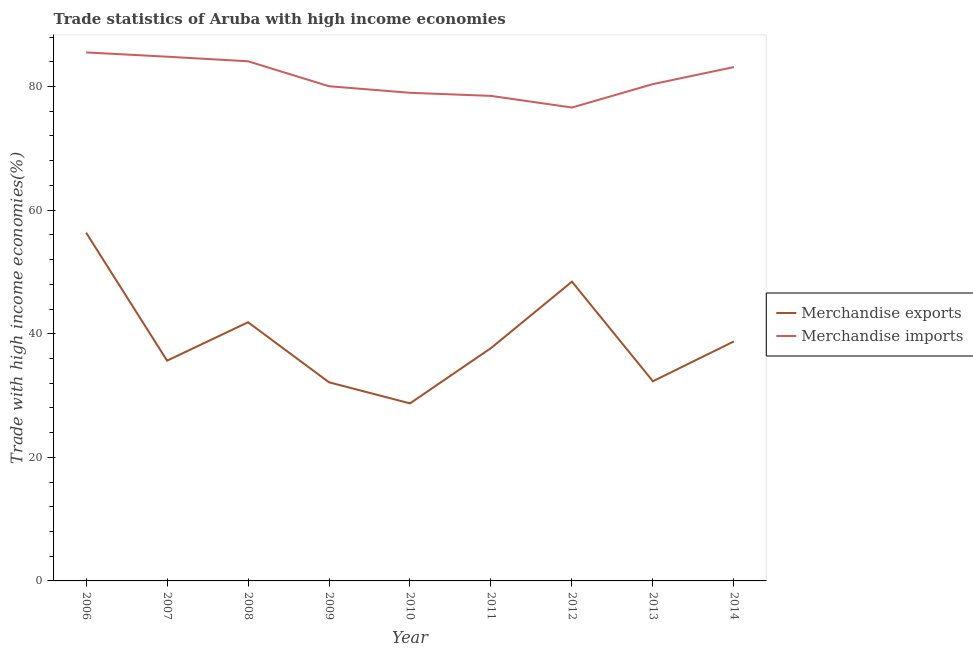What is the merchandise exports in 2008?
Offer a very short reply. 41.86. Across all years, what is the maximum merchandise imports?
Provide a short and direct response. 85.52. Across all years, what is the minimum merchandise imports?
Ensure brevity in your answer.  76.6. In which year was the merchandise imports maximum?
Provide a short and direct response. 2006. In which year was the merchandise exports minimum?
Keep it short and to the point. 2010. What is the total merchandise imports in the graph?
Your answer should be compact. 732.12. What is the difference between the merchandise exports in 2006 and that in 2012?
Your response must be concise. 7.93. What is the difference between the merchandise exports in 2006 and the merchandise imports in 2008?
Keep it short and to the point. -27.73. What is the average merchandise imports per year?
Ensure brevity in your answer.  81.35. In the year 2011, what is the difference between the merchandise exports and merchandise imports?
Your response must be concise. -40.81. What is the ratio of the merchandise imports in 2012 to that in 2013?
Make the answer very short. 0.95. What is the difference between the highest and the second highest merchandise exports?
Provide a short and direct response. 7.93. What is the difference between the highest and the lowest merchandise exports?
Your response must be concise. 27.63. Is the sum of the merchandise imports in 2008 and 2012 greater than the maximum merchandise exports across all years?
Offer a terse response. Yes. Does the merchandise exports monotonically increase over the years?
Give a very brief answer. No. Is the merchandise exports strictly less than the merchandise imports over the years?
Keep it short and to the point. Yes. Are the values on the major ticks of Y-axis written in scientific E-notation?
Ensure brevity in your answer.  No. Does the graph contain any zero values?
Provide a short and direct response. No. Does the graph contain grids?
Provide a short and direct response. No. Where does the legend appear in the graph?
Provide a succinct answer. Center right. How many legend labels are there?
Ensure brevity in your answer.  2. What is the title of the graph?
Provide a short and direct response. Trade statistics of Aruba with high income economies. Does "Measles" appear as one of the legend labels in the graph?
Ensure brevity in your answer.  No. What is the label or title of the X-axis?
Your response must be concise. Year. What is the label or title of the Y-axis?
Provide a short and direct response. Trade with high income economies(%). What is the Trade with high income economies(%) of Merchandise exports in 2006?
Make the answer very short. 56.36. What is the Trade with high income economies(%) of Merchandise imports in 2006?
Your answer should be compact. 85.52. What is the Trade with high income economies(%) of Merchandise exports in 2007?
Make the answer very short. 35.64. What is the Trade with high income economies(%) of Merchandise imports in 2007?
Ensure brevity in your answer.  84.83. What is the Trade with high income economies(%) of Merchandise exports in 2008?
Ensure brevity in your answer.  41.86. What is the Trade with high income economies(%) of Merchandise imports in 2008?
Provide a succinct answer. 84.09. What is the Trade with high income economies(%) of Merchandise exports in 2009?
Your answer should be compact. 32.14. What is the Trade with high income economies(%) of Merchandise imports in 2009?
Your answer should be compact. 80.05. What is the Trade with high income economies(%) of Merchandise exports in 2010?
Your response must be concise. 28.73. What is the Trade with high income economies(%) of Merchandise imports in 2010?
Your answer should be compact. 78.99. What is the Trade with high income economies(%) in Merchandise exports in 2011?
Your answer should be very brief. 37.68. What is the Trade with high income economies(%) of Merchandise imports in 2011?
Keep it short and to the point. 78.49. What is the Trade with high income economies(%) of Merchandise exports in 2012?
Your response must be concise. 48.43. What is the Trade with high income economies(%) of Merchandise imports in 2012?
Offer a very short reply. 76.6. What is the Trade with high income economies(%) in Merchandise exports in 2013?
Offer a terse response. 32.31. What is the Trade with high income economies(%) of Merchandise imports in 2013?
Offer a terse response. 80.39. What is the Trade with high income economies(%) of Merchandise exports in 2014?
Keep it short and to the point. 38.76. What is the Trade with high income economies(%) of Merchandise imports in 2014?
Keep it short and to the point. 83.15. Across all years, what is the maximum Trade with high income economies(%) of Merchandise exports?
Make the answer very short. 56.36. Across all years, what is the maximum Trade with high income economies(%) in Merchandise imports?
Offer a very short reply. 85.52. Across all years, what is the minimum Trade with high income economies(%) of Merchandise exports?
Offer a terse response. 28.73. Across all years, what is the minimum Trade with high income economies(%) of Merchandise imports?
Your response must be concise. 76.6. What is the total Trade with high income economies(%) of Merchandise exports in the graph?
Provide a short and direct response. 351.9. What is the total Trade with high income economies(%) of Merchandise imports in the graph?
Keep it short and to the point. 732.12. What is the difference between the Trade with high income economies(%) in Merchandise exports in 2006 and that in 2007?
Offer a very short reply. 20.72. What is the difference between the Trade with high income economies(%) in Merchandise imports in 2006 and that in 2007?
Provide a short and direct response. 0.69. What is the difference between the Trade with high income economies(%) of Merchandise exports in 2006 and that in 2008?
Your answer should be compact. 14.5. What is the difference between the Trade with high income economies(%) in Merchandise imports in 2006 and that in 2008?
Provide a short and direct response. 1.43. What is the difference between the Trade with high income economies(%) in Merchandise exports in 2006 and that in 2009?
Give a very brief answer. 24.22. What is the difference between the Trade with high income economies(%) of Merchandise imports in 2006 and that in 2009?
Ensure brevity in your answer.  5.47. What is the difference between the Trade with high income economies(%) in Merchandise exports in 2006 and that in 2010?
Provide a short and direct response. 27.63. What is the difference between the Trade with high income economies(%) of Merchandise imports in 2006 and that in 2010?
Make the answer very short. 6.53. What is the difference between the Trade with high income economies(%) of Merchandise exports in 2006 and that in 2011?
Your answer should be very brief. 18.69. What is the difference between the Trade with high income economies(%) of Merchandise imports in 2006 and that in 2011?
Offer a terse response. 7.03. What is the difference between the Trade with high income economies(%) in Merchandise exports in 2006 and that in 2012?
Ensure brevity in your answer.  7.93. What is the difference between the Trade with high income economies(%) in Merchandise imports in 2006 and that in 2012?
Offer a very short reply. 8.92. What is the difference between the Trade with high income economies(%) of Merchandise exports in 2006 and that in 2013?
Provide a short and direct response. 24.05. What is the difference between the Trade with high income economies(%) in Merchandise imports in 2006 and that in 2013?
Give a very brief answer. 5.13. What is the difference between the Trade with high income economies(%) in Merchandise exports in 2006 and that in 2014?
Your answer should be very brief. 17.6. What is the difference between the Trade with high income economies(%) of Merchandise imports in 2006 and that in 2014?
Offer a very short reply. 2.37. What is the difference between the Trade with high income economies(%) in Merchandise exports in 2007 and that in 2008?
Keep it short and to the point. -6.22. What is the difference between the Trade with high income economies(%) of Merchandise imports in 2007 and that in 2008?
Provide a succinct answer. 0.74. What is the difference between the Trade with high income economies(%) in Merchandise exports in 2007 and that in 2009?
Your answer should be compact. 3.5. What is the difference between the Trade with high income economies(%) in Merchandise imports in 2007 and that in 2009?
Provide a short and direct response. 4.78. What is the difference between the Trade with high income economies(%) in Merchandise exports in 2007 and that in 2010?
Your response must be concise. 6.91. What is the difference between the Trade with high income economies(%) of Merchandise imports in 2007 and that in 2010?
Your answer should be compact. 5.84. What is the difference between the Trade with high income economies(%) of Merchandise exports in 2007 and that in 2011?
Provide a succinct answer. -2.04. What is the difference between the Trade with high income economies(%) of Merchandise imports in 2007 and that in 2011?
Ensure brevity in your answer.  6.34. What is the difference between the Trade with high income economies(%) in Merchandise exports in 2007 and that in 2012?
Provide a succinct answer. -12.79. What is the difference between the Trade with high income economies(%) in Merchandise imports in 2007 and that in 2012?
Offer a terse response. 8.23. What is the difference between the Trade with high income economies(%) of Merchandise exports in 2007 and that in 2013?
Offer a terse response. 3.33. What is the difference between the Trade with high income economies(%) in Merchandise imports in 2007 and that in 2013?
Your response must be concise. 4.44. What is the difference between the Trade with high income economies(%) in Merchandise exports in 2007 and that in 2014?
Provide a succinct answer. -3.12. What is the difference between the Trade with high income economies(%) in Merchandise imports in 2007 and that in 2014?
Make the answer very short. 1.68. What is the difference between the Trade with high income economies(%) of Merchandise exports in 2008 and that in 2009?
Your answer should be compact. 9.72. What is the difference between the Trade with high income economies(%) of Merchandise imports in 2008 and that in 2009?
Your response must be concise. 4.04. What is the difference between the Trade with high income economies(%) in Merchandise exports in 2008 and that in 2010?
Keep it short and to the point. 13.13. What is the difference between the Trade with high income economies(%) of Merchandise imports in 2008 and that in 2010?
Offer a terse response. 5.1. What is the difference between the Trade with high income economies(%) in Merchandise exports in 2008 and that in 2011?
Make the answer very short. 4.18. What is the difference between the Trade with high income economies(%) in Merchandise imports in 2008 and that in 2011?
Offer a terse response. 5.6. What is the difference between the Trade with high income economies(%) in Merchandise exports in 2008 and that in 2012?
Your response must be concise. -6.57. What is the difference between the Trade with high income economies(%) in Merchandise imports in 2008 and that in 2012?
Keep it short and to the point. 7.48. What is the difference between the Trade with high income economies(%) in Merchandise exports in 2008 and that in 2013?
Give a very brief answer. 9.55. What is the difference between the Trade with high income economies(%) in Merchandise imports in 2008 and that in 2013?
Your answer should be compact. 3.69. What is the difference between the Trade with high income economies(%) in Merchandise exports in 2008 and that in 2014?
Offer a terse response. 3.1. What is the difference between the Trade with high income economies(%) in Merchandise imports in 2008 and that in 2014?
Your answer should be compact. 0.94. What is the difference between the Trade with high income economies(%) in Merchandise exports in 2009 and that in 2010?
Ensure brevity in your answer.  3.41. What is the difference between the Trade with high income economies(%) of Merchandise imports in 2009 and that in 2010?
Keep it short and to the point. 1.06. What is the difference between the Trade with high income economies(%) of Merchandise exports in 2009 and that in 2011?
Provide a succinct answer. -5.53. What is the difference between the Trade with high income economies(%) of Merchandise imports in 2009 and that in 2011?
Your response must be concise. 1.56. What is the difference between the Trade with high income economies(%) of Merchandise exports in 2009 and that in 2012?
Offer a very short reply. -16.28. What is the difference between the Trade with high income economies(%) of Merchandise imports in 2009 and that in 2012?
Keep it short and to the point. 3.45. What is the difference between the Trade with high income economies(%) in Merchandise exports in 2009 and that in 2013?
Provide a succinct answer. -0.17. What is the difference between the Trade with high income economies(%) of Merchandise imports in 2009 and that in 2013?
Provide a succinct answer. -0.34. What is the difference between the Trade with high income economies(%) in Merchandise exports in 2009 and that in 2014?
Your response must be concise. -6.61. What is the difference between the Trade with high income economies(%) in Merchandise imports in 2009 and that in 2014?
Make the answer very short. -3.1. What is the difference between the Trade with high income economies(%) of Merchandise exports in 2010 and that in 2011?
Your answer should be compact. -8.95. What is the difference between the Trade with high income economies(%) of Merchandise imports in 2010 and that in 2011?
Your answer should be very brief. 0.5. What is the difference between the Trade with high income economies(%) of Merchandise exports in 2010 and that in 2012?
Your answer should be compact. -19.7. What is the difference between the Trade with high income economies(%) of Merchandise imports in 2010 and that in 2012?
Your answer should be very brief. 2.39. What is the difference between the Trade with high income economies(%) of Merchandise exports in 2010 and that in 2013?
Your answer should be very brief. -3.58. What is the difference between the Trade with high income economies(%) in Merchandise imports in 2010 and that in 2013?
Provide a short and direct response. -1.4. What is the difference between the Trade with high income economies(%) in Merchandise exports in 2010 and that in 2014?
Your response must be concise. -10.03. What is the difference between the Trade with high income economies(%) of Merchandise imports in 2010 and that in 2014?
Your response must be concise. -4.16. What is the difference between the Trade with high income economies(%) of Merchandise exports in 2011 and that in 2012?
Offer a very short reply. -10.75. What is the difference between the Trade with high income economies(%) of Merchandise imports in 2011 and that in 2012?
Ensure brevity in your answer.  1.88. What is the difference between the Trade with high income economies(%) of Merchandise exports in 2011 and that in 2013?
Your response must be concise. 5.36. What is the difference between the Trade with high income economies(%) of Merchandise imports in 2011 and that in 2013?
Give a very brief answer. -1.91. What is the difference between the Trade with high income economies(%) of Merchandise exports in 2011 and that in 2014?
Your answer should be very brief. -1.08. What is the difference between the Trade with high income economies(%) in Merchandise imports in 2011 and that in 2014?
Your answer should be compact. -4.66. What is the difference between the Trade with high income economies(%) of Merchandise exports in 2012 and that in 2013?
Ensure brevity in your answer.  16.12. What is the difference between the Trade with high income economies(%) of Merchandise imports in 2012 and that in 2013?
Make the answer very short. -3.79. What is the difference between the Trade with high income economies(%) in Merchandise exports in 2012 and that in 2014?
Your answer should be very brief. 9.67. What is the difference between the Trade with high income economies(%) in Merchandise imports in 2012 and that in 2014?
Give a very brief answer. -6.55. What is the difference between the Trade with high income economies(%) of Merchandise exports in 2013 and that in 2014?
Offer a terse response. -6.45. What is the difference between the Trade with high income economies(%) in Merchandise imports in 2013 and that in 2014?
Offer a terse response. -2.76. What is the difference between the Trade with high income economies(%) in Merchandise exports in 2006 and the Trade with high income economies(%) in Merchandise imports in 2007?
Provide a short and direct response. -28.47. What is the difference between the Trade with high income economies(%) of Merchandise exports in 2006 and the Trade with high income economies(%) of Merchandise imports in 2008?
Offer a very short reply. -27.73. What is the difference between the Trade with high income economies(%) in Merchandise exports in 2006 and the Trade with high income economies(%) in Merchandise imports in 2009?
Keep it short and to the point. -23.69. What is the difference between the Trade with high income economies(%) in Merchandise exports in 2006 and the Trade with high income economies(%) in Merchandise imports in 2010?
Keep it short and to the point. -22.63. What is the difference between the Trade with high income economies(%) of Merchandise exports in 2006 and the Trade with high income economies(%) of Merchandise imports in 2011?
Give a very brief answer. -22.13. What is the difference between the Trade with high income economies(%) in Merchandise exports in 2006 and the Trade with high income economies(%) in Merchandise imports in 2012?
Keep it short and to the point. -20.24. What is the difference between the Trade with high income economies(%) in Merchandise exports in 2006 and the Trade with high income economies(%) in Merchandise imports in 2013?
Offer a very short reply. -24.03. What is the difference between the Trade with high income economies(%) in Merchandise exports in 2006 and the Trade with high income economies(%) in Merchandise imports in 2014?
Provide a short and direct response. -26.79. What is the difference between the Trade with high income economies(%) in Merchandise exports in 2007 and the Trade with high income economies(%) in Merchandise imports in 2008?
Keep it short and to the point. -48.45. What is the difference between the Trade with high income economies(%) in Merchandise exports in 2007 and the Trade with high income economies(%) in Merchandise imports in 2009?
Offer a terse response. -44.41. What is the difference between the Trade with high income economies(%) of Merchandise exports in 2007 and the Trade with high income economies(%) of Merchandise imports in 2010?
Your answer should be compact. -43.35. What is the difference between the Trade with high income economies(%) of Merchandise exports in 2007 and the Trade with high income economies(%) of Merchandise imports in 2011?
Offer a terse response. -42.85. What is the difference between the Trade with high income economies(%) in Merchandise exports in 2007 and the Trade with high income economies(%) in Merchandise imports in 2012?
Keep it short and to the point. -40.96. What is the difference between the Trade with high income economies(%) in Merchandise exports in 2007 and the Trade with high income economies(%) in Merchandise imports in 2013?
Provide a succinct answer. -44.75. What is the difference between the Trade with high income economies(%) of Merchandise exports in 2007 and the Trade with high income economies(%) of Merchandise imports in 2014?
Your answer should be very brief. -47.51. What is the difference between the Trade with high income economies(%) in Merchandise exports in 2008 and the Trade with high income economies(%) in Merchandise imports in 2009?
Provide a succinct answer. -38.19. What is the difference between the Trade with high income economies(%) of Merchandise exports in 2008 and the Trade with high income economies(%) of Merchandise imports in 2010?
Your answer should be compact. -37.13. What is the difference between the Trade with high income economies(%) in Merchandise exports in 2008 and the Trade with high income economies(%) in Merchandise imports in 2011?
Your response must be concise. -36.63. What is the difference between the Trade with high income economies(%) of Merchandise exports in 2008 and the Trade with high income economies(%) of Merchandise imports in 2012?
Your answer should be very brief. -34.75. What is the difference between the Trade with high income economies(%) of Merchandise exports in 2008 and the Trade with high income economies(%) of Merchandise imports in 2013?
Ensure brevity in your answer.  -38.54. What is the difference between the Trade with high income economies(%) in Merchandise exports in 2008 and the Trade with high income economies(%) in Merchandise imports in 2014?
Provide a succinct answer. -41.29. What is the difference between the Trade with high income economies(%) in Merchandise exports in 2009 and the Trade with high income economies(%) in Merchandise imports in 2010?
Keep it short and to the point. -46.85. What is the difference between the Trade with high income economies(%) in Merchandise exports in 2009 and the Trade with high income economies(%) in Merchandise imports in 2011?
Your response must be concise. -46.35. What is the difference between the Trade with high income economies(%) of Merchandise exports in 2009 and the Trade with high income economies(%) of Merchandise imports in 2012?
Your answer should be compact. -44.46. What is the difference between the Trade with high income economies(%) of Merchandise exports in 2009 and the Trade with high income economies(%) of Merchandise imports in 2013?
Provide a succinct answer. -48.25. What is the difference between the Trade with high income economies(%) of Merchandise exports in 2009 and the Trade with high income economies(%) of Merchandise imports in 2014?
Provide a short and direct response. -51.01. What is the difference between the Trade with high income economies(%) in Merchandise exports in 2010 and the Trade with high income economies(%) in Merchandise imports in 2011?
Give a very brief answer. -49.76. What is the difference between the Trade with high income economies(%) in Merchandise exports in 2010 and the Trade with high income economies(%) in Merchandise imports in 2012?
Keep it short and to the point. -47.88. What is the difference between the Trade with high income economies(%) of Merchandise exports in 2010 and the Trade with high income economies(%) of Merchandise imports in 2013?
Offer a very short reply. -51.67. What is the difference between the Trade with high income economies(%) of Merchandise exports in 2010 and the Trade with high income economies(%) of Merchandise imports in 2014?
Your answer should be very brief. -54.42. What is the difference between the Trade with high income economies(%) of Merchandise exports in 2011 and the Trade with high income economies(%) of Merchandise imports in 2012?
Give a very brief answer. -38.93. What is the difference between the Trade with high income economies(%) of Merchandise exports in 2011 and the Trade with high income economies(%) of Merchandise imports in 2013?
Keep it short and to the point. -42.72. What is the difference between the Trade with high income economies(%) in Merchandise exports in 2011 and the Trade with high income economies(%) in Merchandise imports in 2014?
Your answer should be compact. -45.48. What is the difference between the Trade with high income economies(%) of Merchandise exports in 2012 and the Trade with high income economies(%) of Merchandise imports in 2013?
Make the answer very short. -31.97. What is the difference between the Trade with high income economies(%) in Merchandise exports in 2012 and the Trade with high income economies(%) in Merchandise imports in 2014?
Offer a terse response. -34.73. What is the difference between the Trade with high income economies(%) in Merchandise exports in 2013 and the Trade with high income economies(%) in Merchandise imports in 2014?
Your answer should be compact. -50.84. What is the average Trade with high income economies(%) in Merchandise exports per year?
Keep it short and to the point. 39.1. What is the average Trade with high income economies(%) in Merchandise imports per year?
Offer a terse response. 81.35. In the year 2006, what is the difference between the Trade with high income economies(%) of Merchandise exports and Trade with high income economies(%) of Merchandise imports?
Your answer should be very brief. -29.16. In the year 2007, what is the difference between the Trade with high income economies(%) in Merchandise exports and Trade with high income economies(%) in Merchandise imports?
Provide a succinct answer. -49.19. In the year 2008, what is the difference between the Trade with high income economies(%) of Merchandise exports and Trade with high income economies(%) of Merchandise imports?
Your answer should be very brief. -42.23. In the year 2009, what is the difference between the Trade with high income economies(%) in Merchandise exports and Trade with high income economies(%) in Merchandise imports?
Provide a short and direct response. -47.91. In the year 2010, what is the difference between the Trade with high income economies(%) in Merchandise exports and Trade with high income economies(%) in Merchandise imports?
Offer a very short reply. -50.26. In the year 2011, what is the difference between the Trade with high income economies(%) of Merchandise exports and Trade with high income economies(%) of Merchandise imports?
Make the answer very short. -40.81. In the year 2012, what is the difference between the Trade with high income economies(%) in Merchandise exports and Trade with high income economies(%) in Merchandise imports?
Your answer should be compact. -28.18. In the year 2013, what is the difference between the Trade with high income economies(%) of Merchandise exports and Trade with high income economies(%) of Merchandise imports?
Your response must be concise. -48.08. In the year 2014, what is the difference between the Trade with high income economies(%) in Merchandise exports and Trade with high income economies(%) in Merchandise imports?
Ensure brevity in your answer.  -44.4. What is the ratio of the Trade with high income economies(%) of Merchandise exports in 2006 to that in 2007?
Ensure brevity in your answer.  1.58. What is the ratio of the Trade with high income economies(%) of Merchandise exports in 2006 to that in 2008?
Your response must be concise. 1.35. What is the ratio of the Trade with high income economies(%) of Merchandise imports in 2006 to that in 2008?
Give a very brief answer. 1.02. What is the ratio of the Trade with high income economies(%) in Merchandise exports in 2006 to that in 2009?
Keep it short and to the point. 1.75. What is the ratio of the Trade with high income economies(%) in Merchandise imports in 2006 to that in 2009?
Offer a very short reply. 1.07. What is the ratio of the Trade with high income economies(%) of Merchandise exports in 2006 to that in 2010?
Ensure brevity in your answer.  1.96. What is the ratio of the Trade with high income economies(%) in Merchandise imports in 2006 to that in 2010?
Your response must be concise. 1.08. What is the ratio of the Trade with high income economies(%) in Merchandise exports in 2006 to that in 2011?
Provide a short and direct response. 1.5. What is the ratio of the Trade with high income economies(%) of Merchandise imports in 2006 to that in 2011?
Provide a succinct answer. 1.09. What is the ratio of the Trade with high income economies(%) in Merchandise exports in 2006 to that in 2012?
Provide a short and direct response. 1.16. What is the ratio of the Trade with high income economies(%) of Merchandise imports in 2006 to that in 2012?
Make the answer very short. 1.12. What is the ratio of the Trade with high income economies(%) of Merchandise exports in 2006 to that in 2013?
Provide a short and direct response. 1.74. What is the ratio of the Trade with high income economies(%) of Merchandise imports in 2006 to that in 2013?
Keep it short and to the point. 1.06. What is the ratio of the Trade with high income economies(%) of Merchandise exports in 2006 to that in 2014?
Offer a very short reply. 1.45. What is the ratio of the Trade with high income economies(%) of Merchandise imports in 2006 to that in 2014?
Keep it short and to the point. 1.03. What is the ratio of the Trade with high income economies(%) in Merchandise exports in 2007 to that in 2008?
Your response must be concise. 0.85. What is the ratio of the Trade with high income economies(%) of Merchandise imports in 2007 to that in 2008?
Keep it short and to the point. 1.01. What is the ratio of the Trade with high income economies(%) in Merchandise exports in 2007 to that in 2009?
Make the answer very short. 1.11. What is the ratio of the Trade with high income economies(%) in Merchandise imports in 2007 to that in 2009?
Make the answer very short. 1.06. What is the ratio of the Trade with high income economies(%) of Merchandise exports in 2007 to that in 2010?
Ensure brevity in your answer.  1.24. What is the ratio of the Trade with high income economies(%) of Merchandise imports in 2007 to that in 2010?
Your answer should be compact. 1.07. What is the ratio of the Trade with high income economies(%) of Merchandise exports in 2007 to that in 2011?
Offer a very short reply. 0.95. What is the ratio of the Trade with high income economies(%) in Merchandise imports in 2007 to that in 2011?
Offer a terse response. 1.08. What is the ratio of the Trade with high income economies(%) in Merchandise exports in 2007 to that in 2012?
Give a very brief answer. 0.74. What is the ratio of the Trade with high income economies(%) of Merchandise imports in 2007 to that in 2012?
Offer a terse response. 1.11. What is the ratio of the Trade with high income economies(%) in Merchandise exports in 2007 to that in 2013?
Offer a very short reply. 1.1. What is the ratio of the Trade with high income economies(%) in Merchandise imports in 2007 to that in 2013?
Offer a terse response. 1.06. What is the ratio of the Trade with high income economies(%) in Merchandise exports in 2007 to that in 2014?
Offer a very short reply. 0.92. What is the ratio of the Trade with high income economies(%) of Merchandise imports in 2007 to that in 2014?
Your answer should be compact. 1.02. What is the ratio of the Trade with high income economies(%) of Merchandise exports in 2008 to that in 2009?
Your response must be concise. 1.3. What is the ratio of the Trade with high income economies(%) in Merchandise imports in 2008 to that in 2009?
Your answer should be very brief. 1.05. What is the ratio of the Trade with high income economies(%) of Merchandise exports in 2008 to that in 2010?
Offer a very short reply. 1.46. What is the ratio of the Trade with high income economies(%) of Merchandise imports in 2008 to that in 2010?
Make the answer very short. 1.06. What is the ratio of the Trade with high income economies(%) of Merchandise exports in 2008 to that in 2011?
Offer a terse response. 1.11. What is the ratio of the Trade with high income economies(%) of Merchandise imports in 2008 to that in 2011?
Provide a short and direct response. 1.07. What is the ratio of the Trade with high income economies(%) in Merchandise exports in 2008 to that in 2012?
Provide a succinct answer. 0.86. What is the ratio of the Trade with high income economies(%) of Merchandise imports in 2008 to that in 2012?
Offer a very short reply. 1.1. What is the ratio of the Trade with high income economies(%) in Merchandise exports in 2008 to that in 2013?
Keep it short and to the point. 1.3. What is the ratio of the Trade with high income economies(%) of Merchandise imports in 2008 to that in 2013?
Offer a terse response. 1.05. What is the ratio of the Trade with high income economies(%) of Merchandise imports in 2008 to that in 2014?
Offer a very short reply. 1.01. What is the ratio of the Trade with high income economies(%) in Merchandise exports in 2009 to that in 2010?
Provide a succinct answer. 1.12. What is the ratio of the Trade with high income economies(%) in Merchandise imports in 2009 to that in 2010?
Make the answer very short. 1.01. What is the ratio of the Trade with high income economies(%) in Merchandise exports in 2009 to that in 2011?
Give a very brief answer. 0.85. What is the ratio of the Trade with high income economies(%) in Merchandise imports in 2009 to that in 2011?
Your response must be concise. 1.02. What is the ratio of the Trade with high income economies(%) of Merchandise exports in 2009 to that in 2012?
Keep it short and to the point. 0.66. What is the ratio of the Trade with high income economies(%) of Merchandise imports in 2009 to that in 2012?
Ensure brevity in your answer.  1.04. What is the ratio of the Trade with high income economies(%) of Merchandise imports in 2009 to that in 2013?
Provide a short and direct response. 1. What is the ratio of the Trade with high income economies(%) of Merchandise exports in 2009 to that in 2014?
Offer a terse response. 0.83. What is the ratio of the Trade with high income economies(%) in Merchandise imports in 2009 to that in 2014?
Keep it short and to the point. 0.96. What is the ratio of the Trade with high income economies(%) in Merchandise exports in 2010 to that in 2011?
Ensure brevity in your answer.  0.76. What is the ratio of the Trade with high income economies(%) of Merchandise imports in 2010 to that in 2011?
Your answer should be compact. 1.01. What is the ratio of the Trade with high income economies(%) in Merchandise exports in 2010 to that in 2012?
Your answer should be compact. 0.59. What is the ratio of the Trade with high income economies(%) in Merchandise imports in 2010 to that in 2012?
Your answer should be compact. 1.03. What is the ratio of the Trade with high income economies(%) of Merchandise exports in 2010 to that in 2013?
Your answer should be compact. 0.89. What is the ratio of the Trade with high income economies(%) of Merchandise imports in 2010 to that in 2013?
Offer a terse response. 0.98. What is the ratio of the Trade with high income economies(%) of Merchandise exports in 2010 to that in 2014?
Keep it short and to the point. 0.74. What is the ratio of the Trade with high income economies(%) of Merchandise imports in 2010 to that in 2014?
Ensure brevity in your answer.  0.95. What is the ratio of the Trade with high income economies(%) in Merchandise exports in 2011 to that in 2012?
Provide a short and direct response. 0.78. What is the ratio of the Trade with high income economies(%) in Merchandise imports in 2011 to that in 2012?
Keep it short and to the point. 1.02. What is the ratio of the Trade with high income economies(%) of Merchandise exports in 2011 to that in 2013?
Keep it short and to the point. 1.17. What is the ratio of the Trade with high income economies(%) of Merchandise imports in 2011 to that in 2013?
Your response must be concise. 0.98. What is the ratio of the Trade with high income economies(%) in Merchandise exports in 2011 to that in 2014?
Your response must be concise. 0.97. What is the ratio of the Trade with high income economies(%) in Merchandise imports in 2011 to that in 2014?
Ensure brevity in your answer.  0.94. What is the ratio of the Trade with high income economies(%) of Merchandise exports in 2012 to that in 2013?
Make the answer very short. 1.5. What is the ratio of the Trade with high income economies(%) of Merchandise imports in 2012 to that in 2013?
Ensure brevity in your answer.  0.95. What is the ratio of the Trade with high income economies(%) of Merchandise exports in 2012 to that in 2014?
Make the answer very short. 1.25. What is the ratio of the Trade with high income economies(%) of Merchandise imports in 2012 to that in 2014?
Keep it short and to the point. 0.92. What is the ratio of the Trade with high income economies(%) in Merchandise exports in 2013 to that in 2014?
Keep it short and to the point. 0.83. What is the ratio of the Trade with high income economies(%) of Merchandise imports in 2013 to that in 2014?
Make the answer very short. 0.97. What is the difference between the highest and the second highest Trade with high income economies(%) in Merchandise exports?
Keep it short and to the point. 7.93. What is the difference between the highest and the second highest Trade with high income economies(%) in Merchandise imports?
Provide a succinct answer. 0.69. What is the difference between the highest and the lowest Trade with high income economies(%) in Merchandise exports?
Your answer should be compact. 27.63. What is the difference between the highest and the lowest Trade with high income economies(%) in Merchandise imports?
Provide a succinct answer. 8.92. 